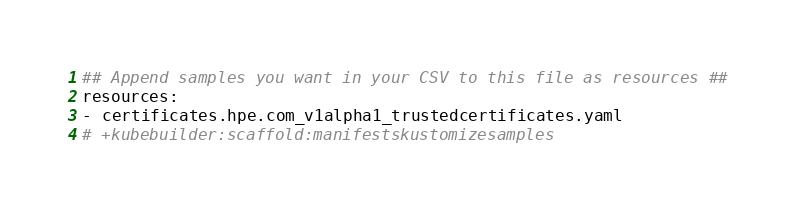Convert code to text. <code><loc_0><loc_0><loc_500><loc_500><_YAML_>## Append samples you want in your CSV to this file as resources ##
resources:
- certificates.hpe.com_v1alpha1_trustedcertificates.yaml
# +kubebuilder:scaffold:manifestskustomizesamples
</code> 